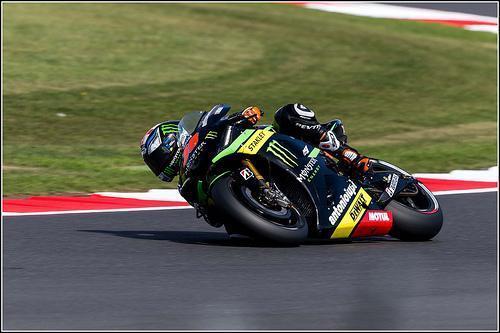How many people are shown?
Give a very brief answer. 1. 